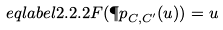Convert formula to latex. <formula><loc_0><loc_0><loc_500><loc_500>\ e q l a b e l { 2 . 2 . 2 } F ( { \P p } _ { C , C ^ { \prime } } ( u ) ) = u</formula> 